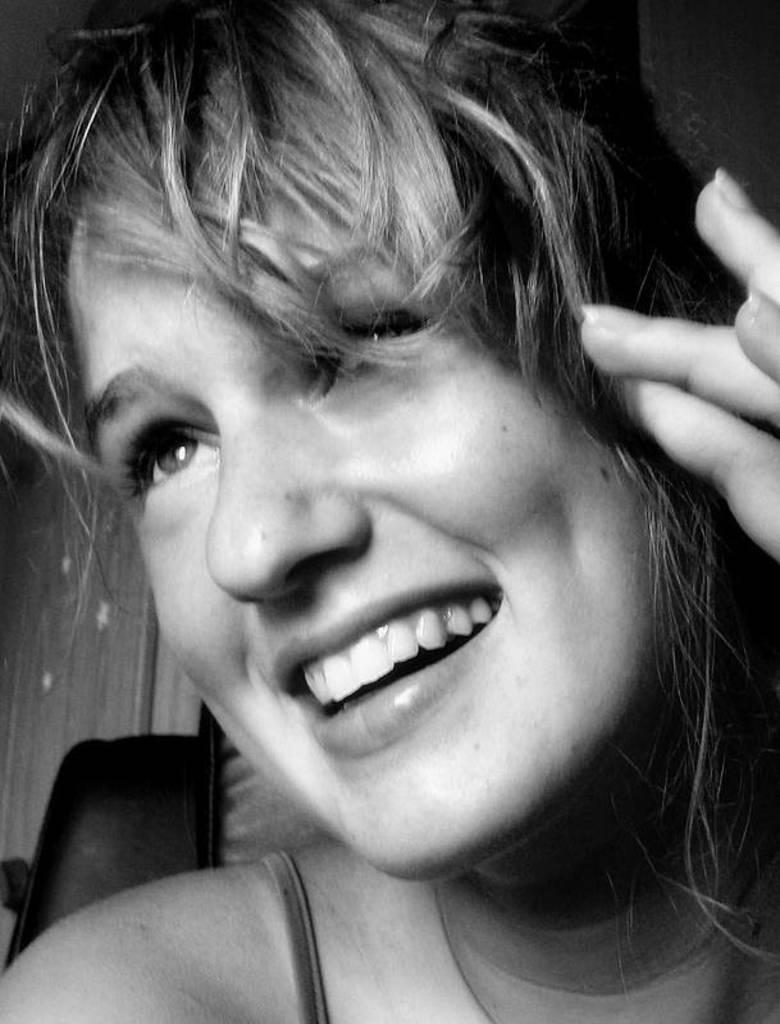Who is present in the image? There is a woman in the image. What type of tent does the woman have in the image? There is no tent present in the image; it only features a woman. How does the woman push the rat away in the image? There is no rat present in the image, so the woman cannot push it away. 